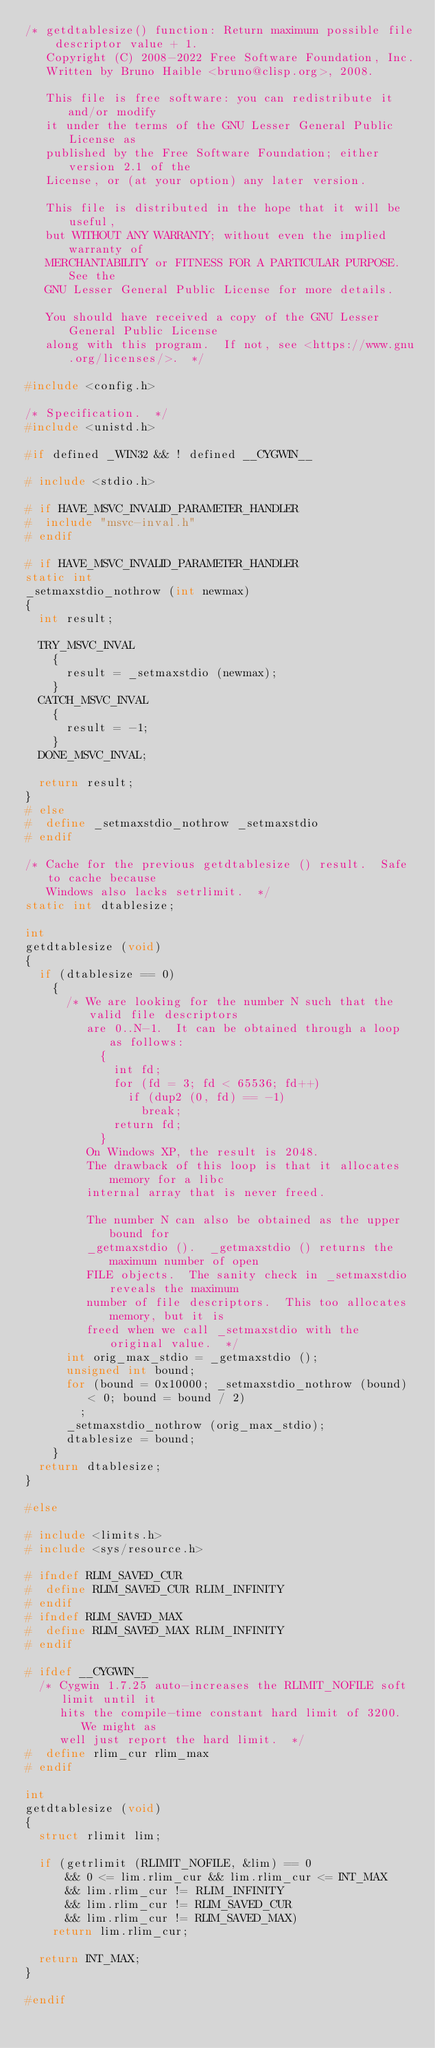Convert code to text. <code><loc_0><loc_0><loc_500><loc_500><_C_>/* getdtablesize() function: Return maximum possible file descriptor value + 1.
   Copyright (C) 2008-2022 Free Software Foundation, Inc.
   Written by Bruno Haible <bruno@clisp.org>, 2008.

   This file is free software: you can redistribute it and/or modify
   it under the terms of the GNU Lesser General Public License as
   published by the Free Software Foundation; either version 2.1 of the
   License, or (at your option) any later version.

   This file is distributed in the hope that it will be useful,
   but WITHOUT ANY WARRANTY; without even the implied warranty of
   MERCHANTABILITY or FITNESS FOR A PARTICULAR PURPOSE.  See the
   GNU Lesser General Public License for more details.

   You should have received a copy of the GNU Lesser General Public License
   along with this program.  If not, see <https://www.gnu.org/licenses/>.  */

#include <config.h>

/* Specification.  */
#include <unistd.h>

#if defined _WIN32 && ! defined __CYGWIN__

# include <stdio.h>

# if HAVE_MSVC_INVALID_PARAMETER_HANDLER
#  include "msvc-inval.h"
# endif

# if HAVE_MSVC_INVALID_PARAMETER_HANDLER
static int
_setmaxstdio_nothrow (int newmax)
{
  int result;

  TRY_MSVC_INVAL
    {
      result = _setmaxstdio (newmax);
    }
  CATCH_MSVC_INVAL
    {
      result = -1;
    }
  DONE_MSVC_INVAL;

  return result;
}
# else
#  define _setmaxstdio_nothrow _setmaxstdio
# endif

/* Cache for the previous getdtablesize () result.  Safe to cache because
   Windows also lacks setrlimit.  */
static int dtablesize;

int
getdtablesize (void)
{
  if (dtablesize == 0)
    {
      /* We are looking for the number N such that the valid file descriptors
         are 0..N-1.  It can be obtained through a loop as follows:
           {
             int fd;
             for (fd = 3; fd < 65536; fd++)
               if (dup2 (0, fd) == -1)
                 break;
             return fd;
           }
         On Windows XP, the result is 2048.
         The drawback of this loop is that it allocates memory for a libc
         internal array that is never freed.

         The number N can also be obtained as the upper bound for
         _getmaxstdio ().  _getmaxstdio () returns the maximum number of open
         FILE objects.  The sanity check in _setmaxstdio reveals the maximum
         number of file descriptors.  This too allocates memory, but it is
         freed when we call _setmaxstdio with the original value.  */
      int orig_max_stdio = _getmaxstdio ();
      unsigned int bound;
      for (bound = 0x10000; _setmaxstdio_nothrow (bound) < 0; bound = bound / 2)
        ;
      _setmaxstdio_nothrow (orig_max_stdio);
      dtablesize = bound;
    }
  return dtablesize;
}

#else

# include <limits.h>
# include <sys/resource.h>

# ifndef RLIM_SAVED_CUR
#  define RLIM_SAVED_CUR RLIM_INFINITY
# endif
# ifndef RLIM_SAVED_MAX
#  define RLIM_SAVED_MAX RLIM_INFINITY
# endif

# ifdef __CYGWIN__
  /* Cygwin 1.7.25 auto-increases the RLIMIT_NOFILE soft limit until it
     hits the compile-time constant hard limit of 3200.  We might as
     well just report the hard limit.  */
#  define rlim_cur rlim_max
# endif

int
getdtablesize (void)
{
  struct rlimit lim;

  if (getrlimit (RLIMIT_NOFILE, &lim) == 0
      && 0 <= lim.rlim_cur && lim.rlim_cur <= INT_MAX
      && lim.rlim_cur != RLIM_INFINITY
      && lim.rlim_cur != RLIM_SAVED_CUR
      && lim.rlim_cur != RLIM_SAVED_MAX)
    return lim.rlim_cur;

  return INT_MAX;
}

#endif
</code> 